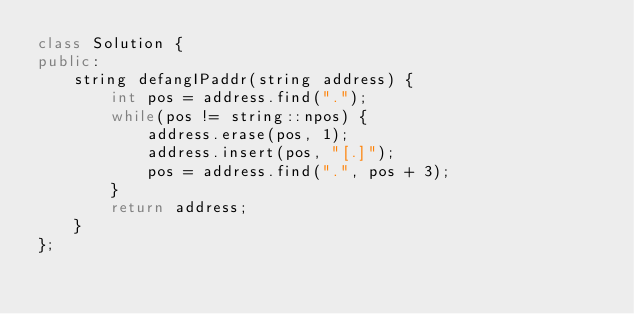<code> <loc_0><loc_0><loc_500><loc_500><_C++_>class Solution {
public:
    string defangIPaddr(string address) {
        int pos = address.find(".");
        while(pos != string::npos) {
            address.erase(pos, 1);
            address.insert(pos, "[.]");
            pos = address.find(".", pos + 3);
        }
        return address;
    }
};</code> 